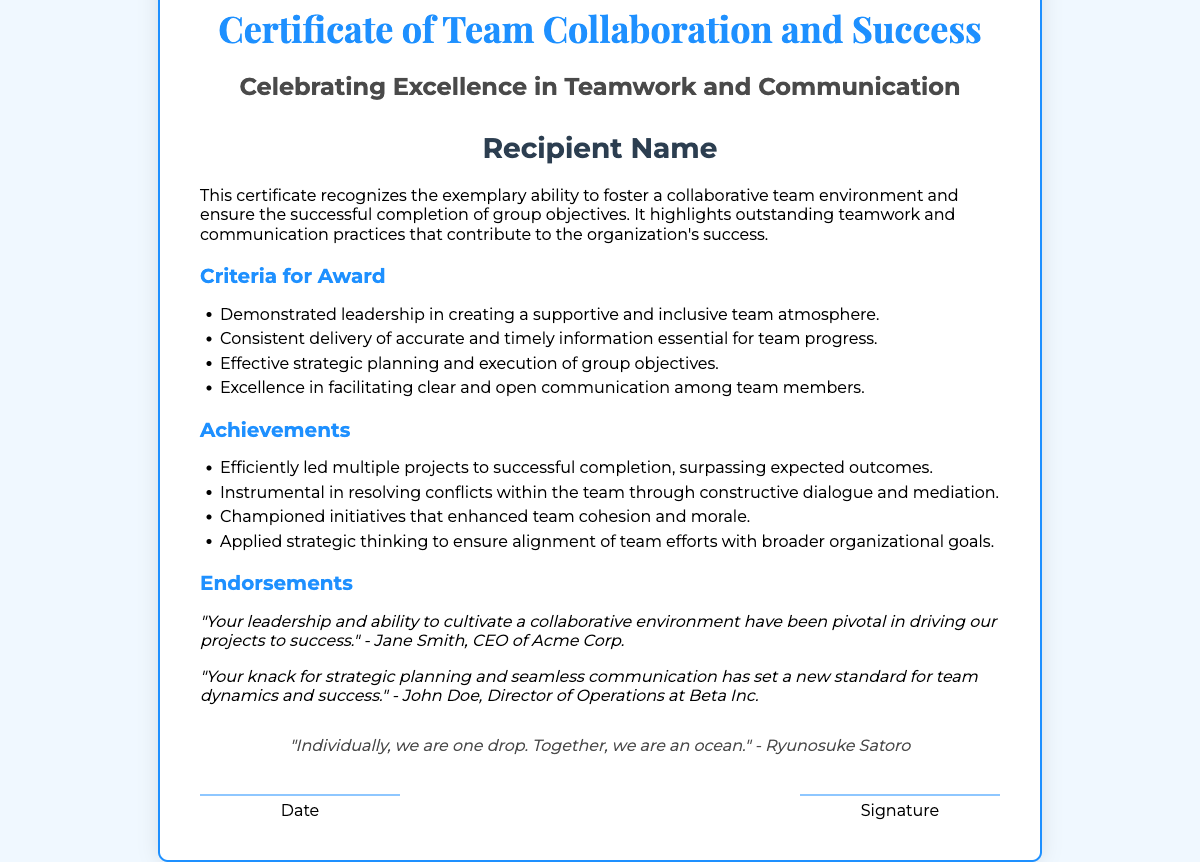What is the title of the certificate? The title is prominently displayed at the top of the certificate, stating its purpose.
Answer: Certificate of Team Collaboration and Success Who is the recipient of the certificate? The recipient's name is typically indicated in the designated area within the certificate.
Answer: Recipient Name What color is the border of the certificate? The certificate features a specific color for its border that highlights its design.
Answer: #1e90ff What is one of the criteria for the award? The criteria are listed in bullet points, detailing the expectations for the award recipient.
Answer: Demonstrated leadership in creating a supportive and inclusive team atmosphere How many endorsements are included in the document? The endorsements section contains statements from different individuals regarding the recipient's contributions.
Answer: 2 What is the quote included in the certificate? The certificate features a motivational quote related to teamwork, which adds a philosophical touch.
Answer: "Individually, we are one drop. Together, we are an ocean." - Ryunosuke Satoro Who is one of the endorsers mentioned? The endorsements section lists individuals who provided commendations for the recipient's achievements.
Answer: Jane Smith What type of document is this? This document serves a specific purpose and format, representing recognition of certain achievements.
Answer: Certificate 